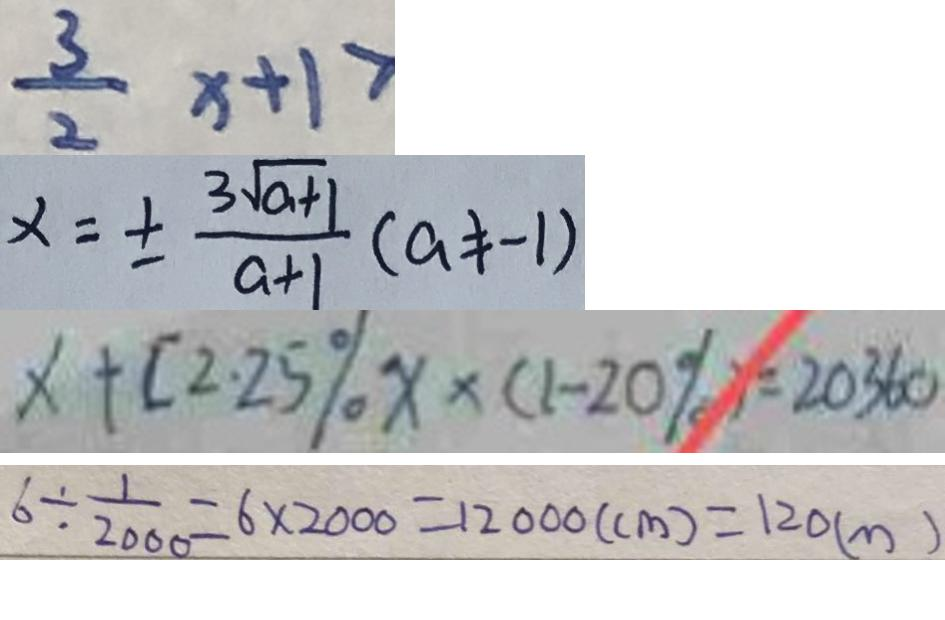Convert formula to latex. <formula><loc_0><loc_0><loc_500><loc_500>\frac { 3 } { 2 } x + 1 > 
 x = \pm \frac { 3 \sqrt { a + 1 } } { a + 1 } ( a \neq - 1 ) 
 x + [ 2 . 2 5 \% x x \times ( 1 - 2 0 \% ) = 2 0 3 6 0 
 6 \div \frac { 1 } { 2 0 0 0 } = 6 \times 2 0 0 0 = 1 2 0 0 0 ( c m ) = 1 2 0 ( m )</formula> 